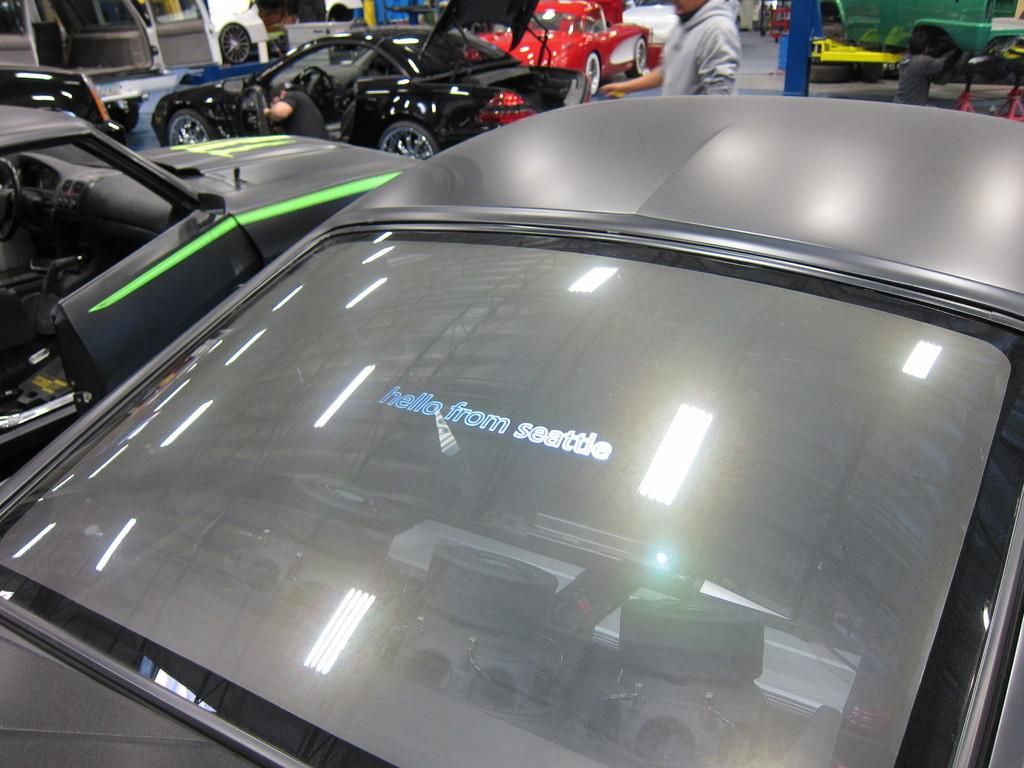What types of objects are present in the image? There are vehicles and people in the image. Can you describe the vehicles in the image? There is a car with some text in the image. What else can be seen in the image besides the vehicles? There are people in the image. What type of jeans is the person wearing in the image? There is no information about the type of jeans the person might be wearing in the image. --- Facts: 1. There is a person holding a book in the image. 2. The book has a title on the cover. 3. The person is sitting on a chair. 4. There is a table in the image. Absurd Topics: parrot, ocean, bicycle Conversation: What is the person in the image holding? The person is holding a book in the image. What can be seen on the book's cover? The book has a title on the cover. Where is the person sitting in the image? The person is sitting on a chair. What other piece of furniture is present in the image? There is a table in the image. Reasoning: Let's think step by step in order to produce the conversation. We start by identifying the main subject in the image, which is the person holding a book. Then, we expand the conversation to include other details about the book, such as the title on the cover. Next, we describe the person's position and the presence of a chair. Finally, we mention the table as another piece of furniture in the image. Absurd Question/Answer: Can you see a parrot sitting on the person's shoulder in the image? No, there is no parrot present in the image. --- Facts: 1. There is a person standing near a tree in the image. 2. The person is holding a camera. 3. The tree has leaves on it. 4. The sky is visible in the image. Absurd Topics: guitar, rain, fence Conversation: What is the person in the image doing? The person is standing near a tree in the image. What is the person holding? The person is holding a camera. Can you describe the tree in the image? The tree has leaves on it. What else can be seen in the image besides the person and the tree? The sky is visible in the image. Reasoning: Let's think step by step in order to produce the conversation. We start by identifying the main subject in the image, which is the person standing near a tree. Then, we describe the person's action, mentioning that they are holding a camera. Next, we focus on the tree, noting that it has leaves on it. Finally, we mention the sky as another element visible in the image. Absurd Question/Answer: 